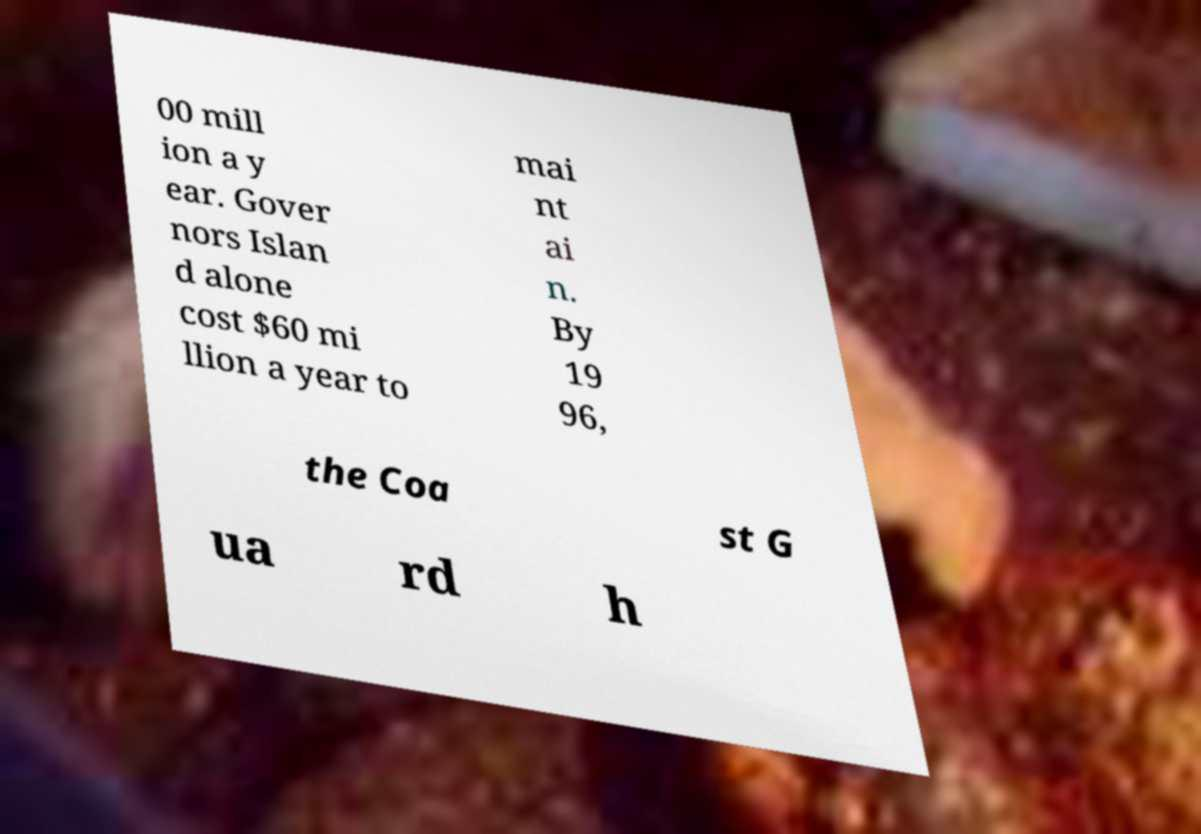Can you read and provide the text displayed in the image?This photo seems to have some interesting text. Can you extract and type it out for me? 00 mill ion a y ear. Gover nors Islan d alone cost $60 mi llion a year to mai nt ai n. By 19 96, the Coa st G ua rd h 